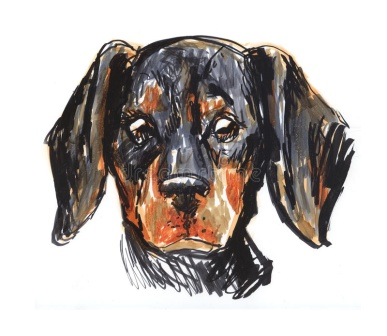Can you elaborate on the elements of the picture provided? Certainly! The image displays a touching illustration of a dachshund puppy. The puppy's distinctive black and brown coat is carefully detailed, making it the focal point of the artwork. Its floppy ears hang down, adding to the expressive, almost sorrowful look in its eyes, which can evoke empathy in anyone who views it. The puppy's expression, closely observing the viewer, creates a sense of connection, as if it's silently communicating. The illustration employs a loose and sketchy style, skillfully using black and orange ink strokes to provide a whimsical yet heartwarming effect. The entire composition is straightforward, focusing solely on the puppy, with no other elements or text to distract from its central presence. The puppy is perfectly centered in the image, enhancing its prominence and inviting viewers to engage with it more intimately. 